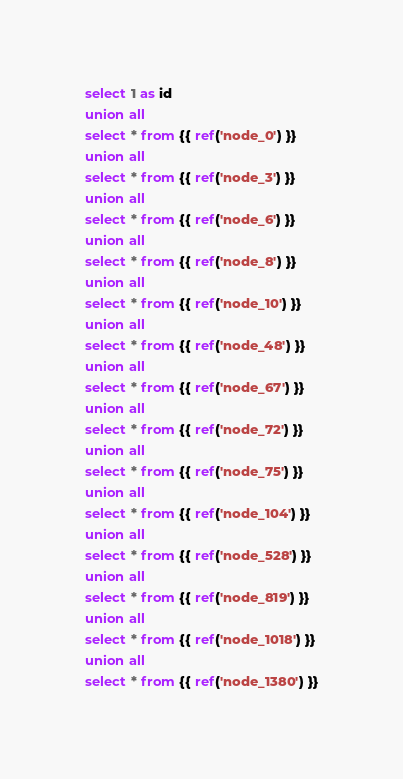<code> <loc_0><loc_0><loc_500><loc_500><_SQL_>select 1 as id
union all
select * from {{ ref('node_0') }}
union all
select * from {{ ref('node_3') }}
union all
select * from {{ ref('node_6') }}
union all
select * from {{ ref('node_8') }}
union all
select * from {{ ref('node_10') }}
union all
select * from {{ ref('node_48') }}
union all
select * from {{ ref('node_67') }}
union all
select * from {{ ref('node_72') }}
union all
select * from {{ ref('node_75') }}
union all
select * from {{ ref('node_104') }}
union all
select * from {{ ref('node_528') }}
union all
select * from {{ ref('node_819') }}
union all
select * from {{ ref('node_1018') }}
union all
select * from {{ ref('node_1380') }}
</code> 